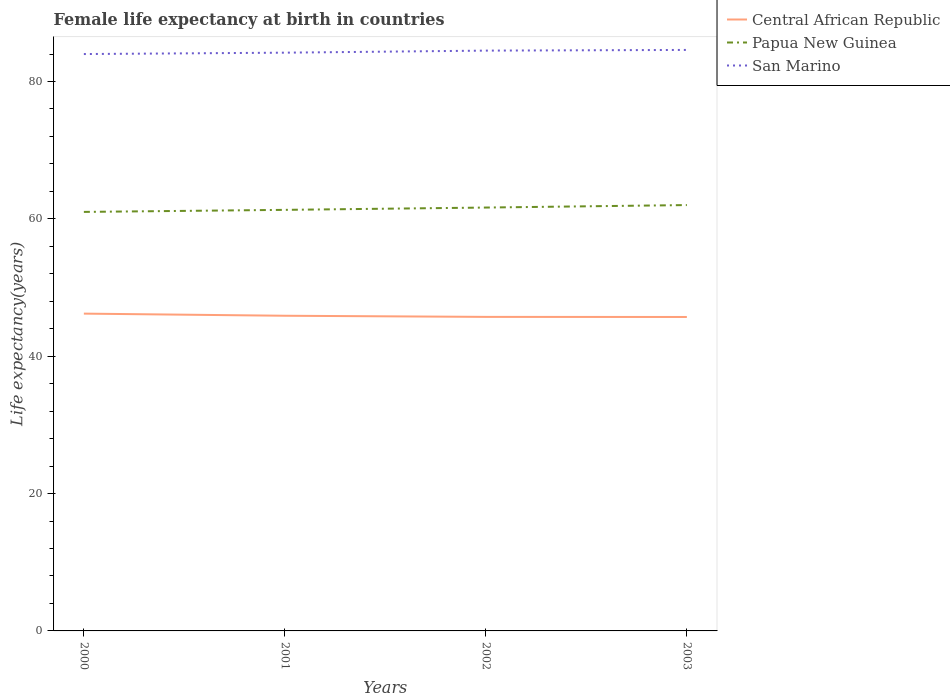How many different coloured lines are there?
Offer a very short reply. 3. In which year was the female life expectancy at birth in Central African Republic maximum?
Offer a very short reply. 2003. What is the total female life expectancy at birth in San Marino in the graph?
Your answer should be very brief. -0.1. What is the difference between the highest and the second highest female life expectancy at birth in Papua New Guinea?
Provide a short and direct response. 1. What is the difference between the highest and the lowest female life expectancy at birth in Papua New Guinea?
Your answer should be compact. 2. Is the female life expectancy at birth in Central African Republic strictly greater than the female life expectancy at birth in San Marino over the years?
Keep it short and to the point. Yes. What is the difference between two consecutive major ticks on the Y-axis?
Offer a terse response. 20. Are the values on the major ticks of Y-axis written in scientific E-notation?
Your answer should be compact. No. Where does the legend appear in the graph?
Provide a short and direct response. Top right. How many legend labels are there?
Ensure brevity in your answer.  3. How are the legend labels stacked?
Your response must be concise. Vertical. What is the title of the graph?
Ensure brevity in your answer.  Female life expectancy at birth in countries. What is the label or title of the X-axis?
Your answer should be compact. Years. What is the label or title of the Y-axis?
Offer a very short reply. Life expectancy(years). What is the Life expectancy(years) in Central African Republic in 2000?
Keep it short and to the point. 46.2. What is the Life expectancy(years) of Papua New Guinea in 2000?
Offer a terse response. 61.01. What is the Life expectancy(years) of San Marino in 2000?
Provide a short and direct response. 84. What is the Life expectancy(years) of Central African Republic in 2001?
Your response must be concise. 45.89. What is the Life expectancy(years) in Papua New Guinea in 2001?
Keep it short and to the point. 61.31. What is the Life expectancy(years) of San Marino in 2001?
Ensure brevity in your answer.  84.2. What is the Life expectancy(years) of Central African Republic in 2002?
Give a very brief answer. 45.73. What is the Life expectancy(years) of Papua New Guinea in 2002?
Offer a terse response. 61.65. What is the Life expectancy(years) of San Marino in 2002?
Give a very brief answer. 84.5. What is the Life expectancy(years) of Central African Republic in 2003?
Provide a short and direct response. 45.71. What is the Life expectancy(years) of Papua New Guinea in 2003?
Provide a succinct answer. 62.01. What is the Life expectancy(years) in San Marino in 2003?
Give a very brief answer. 84.6. Across all years, what is the maximum Life expectancy(years) in Central African Republic?
Offer a very short reply. 46.2. Across all years, what is the maximum Life expectancy(years) in Papua New Guinea?
Provide a succinct answer. 62.01. Across all years, what is the maximum Life expectancy(years) of San Marino?
Make the answer very short. 84.6. Across all years, what is the minimum Life expectancy(years) of Central African Republic?
Ensure brevity in your answer.  45.71. Across all years, what is the minimum Life expectancy(years) of Papua New Guinea?
Keep it short and to the point. 61.01. Across all years, what is the minimum Life expectancy(years) of San Marino?
Your answer should be compact. 84. What is the total Life expectancy(years) of Central African Republic in the graph?
Provide a short and direct response. 183.53. What is the total Life expectancy(years) in Papua New Guinea in the graph?
Provide a short and direct response. 245.98. What is the total Life expectancy(years) of San Marino in the graph?
Make the answer very short. 337.3. What is the difference between the Life expectancy(years) of Central African Republic in 2000 and that in 2001?
Offer a very short reply. 0.31. What is the difference between the Life expectancy(years) of Papua New Guinea in 2000 and that in 2001?
Your response must be concise. -0.3. What is the difference between the Life expectancy(years) of Central African Republic in 2000 and that in 2002?
Ensure brevity in your answer.  0.47. What is the difference between the Life expectancy(years) of Papua New Guinea in 2000 and that in 2002?
Keep it short and to the point. -0.64. What is the difference between the Life expectancy(years) of Central African Republic in 2000 and that in 2003?
Provide a succinct answer. 0.49. What is the difference between the Life expectancy(years) in Papua New Guinea in 2000 and that in 2003?
Give a very brief answer. -1. What is the difference between the Life expectancy(years) in San Marino in 2000 and that in 2003?
Your response must be concise. -0.6. What is the difference between the Life expectancy(years) of Central African Republic in 2001 and that in 2002?
Provide a succinct answer. 0.17. What is the difference between the Life expectancy(years) of Papua New Guinea in 2001 and that in 2002?
Provide a succinct answer. -0.34. What is the difference between the Life expectancy(years) of San Marino in 2001 and that in 2002?
Make the answer very short. -0.3. What is the difference between the Life expectancy(years) of Central African Republic in 2001 and that in 2003?
Give a very brief answer. 0.18. What is the difference between the Life expectancy(years) in Papua New Guinea in 2001 and that in 2003?
Your response must be concise. -0.7. What is the difference between the Life expectancy(years) in San Marino in 2001 and that in 2003?
Offer a terse response. -0.4. What is the difference between the Life expectancy(years) in Central African Republic in 2002 and that in 2003?
Your response must be concise. 0.01. What is the difference between the Life expectancy(years) of Papua New Guinea in 2002 and that in 2003?
Give a very brief answer. -0.36. What is the difference between the Life expectancy(years) in San Marino in 2002 and that in 2003?
Your answer should be very brief. -0.1. What is the difference between the Life expectancy(years) in Central African Republic in 2000 and the Life expectancy(years) in Papua New Guinea in 2001?
Provide a short and direct response. -15.11. What is the difference between the Life expectancy(years) of Central African Republic in 2000 and the Life expectancy(years) of San Marino in 2001?
Ensure brevity in your answer.  -38. What is the difference between the Life expectancy(years) of Papua New Guinea in 2000 and the Life expectancy(years) of San Marino in 2001?
Your response must be concise. -23.19. What is the difference between the Life expectancy(years) of Central African Republic in 2000 and the Life expectancy(years) of Papua New Guinea in 2002?
Offer a very short reply. -15.45. What is the difference between the Life expectancy(years) in Central African Republic in 2000 and the Life expectancy(years) in San Marino in 2002?
Your answer should be compact. -38.3. What is the difference between the Life expectancy(years) in Papua New Guinea in 2000 and the Life expectancy(years) in San Marino in 2002?
Offer a very short reply. -23.49. What is the difference between the Life expectancy(years) in Central African Republic in 2000 and the Life expectancy(years) in Papua New Guinea in 2003?
Offer a very short reply. -15.81. What is the difference between the Life expectancy(years) in Central African Republic in 2000 and the Life expectancy(years) in San Marino in 2003?
Your answer should be very brief. -38.4. What is the difference between the Life expectancy(years) in Papua New Guinea in 2000 and the Life expectancy(years) in San Marino in 2003?
Your response must be concise. -23.59. What is the difference between the Life expectancy(years) in Central African Republic in 2001 and the Life expectancy(years) in Papua New Guinea in 2002?
Your answer should be compact. -15.76. What is the difference between the Life expectancy(years) of Central African Republic in 2001 and the Life expectancy(years) of San Marino in 2002?
Your answer should be very brief. -38.61. What is the difference between the Life expectancy(years) in Papua New Guinea in 2001 and the Life expectancy(years) in San Marino in 2002?
Your answer should be compact. -23.19. What is the difference between the Life expectancy(years) in Central African Republic in 2001 and the Life expectancy(years) in Papua New Guinea in 2003?
Your answer should be very brief. -16.12. What is the difference between the Life expectancy(years) of Central African Republic in 2001 and the Life expectancy(years) of San Marino in 2003?
Your answer should be compact. -38.71. What is the difference between the Life expectancy(years) in Papua New Guinea in 2001 and the Life expectancy(years) in San Marino in 2003?
Your answer should be very brief. -23.29. What is the difference between the Life expectancy(years) of Central African Republic in 2002 and the Life expectancy(years) of Papua New Guinea in 2003?
Ensure brevity in your answer.  -16.28. What is the difference between the Life expectancy(years) of Central African Republic in 2002 and the Life expectancy(years) of San Marino in 2003?
Your response must be concise. -38.87. What is the difference between the Life expectancy(years) in Papua New Guinea in 2002 and the Life expectancy(years) in San Marino in 2003?
Your answer should be very brief. -22.95. What is the average Life expectancy(years) of Central African Republic per year?
Offer a very short reply. 45.88. What is the average Life expectancy(years) in Papua New Guinea per year?
Provide a succinct answer. 61.5. What is the average Life expectancy(years) in San Marino per year?
Your response must be concise. 84.33. In the year 2000, what is the difference between the Life expectancy(years) of Central African Republic and Life expectancy(years) of Papua New Guinea?
Your answer should be compact. -14.81. In the year 2000, what is the difference between the Life expectancy(years) of Central African Republic and Life expectancy(years) of San Marino?
Make the answer very short. -37.8. In the year 2000, what is the difference between the Life expectancy(years) in Papua New Guinea and Life expectancy(years) in San Marino?
Your response must be concise. -22.99. In the year 2001, what is the difference between the Life expectancy(years) of Central African Republic and Life expectancy(years) of Papua New Guinea?
Provide a succinct answer. -15.42. In the year 2001, what is the difference between the Life expectancy(years) in Central African Republic and Life expectancy(years) in San Marino?
Give a very brief answer. -38.31. In the year 2001, what is the difference between the Life expectancy(years) in Papua New Guinea and Life expectancy(years) in San Marino?
Your answer should be very brief. -22.89. In the year 2002, what is the difference between the Life expectancy(years) of Central African Republic and Life expectancy(years) of Papua New Guinea?
Keep it short and to the point. -15.92. In the year 2002, what is the difference between the Life expectancy(years) of Central African Republic and Life expectancy(years) of San Marino?
Your answer should be very brief. -38.77. In the year 2002, what is the difference between the Life expectancy(years) in Papua New Guinea and Life expectancy(years) in San Marino?
Offer a very short reply. -22.85. In the year 2003, what is the difference between the Life expectancy(years) in Central African Republic and Life expectancy(years) in Papua New Guinea?
Ensure brevity in your answer.  -16.3. In the year 2003, what is the difference between the Life expectancy(years) of Central African Republic and Life expectancy(years) of San Marino?
Ensure brevity in your answer.  -38.89. In the year 2003, what is the difference between the Life expectancy(years) in Papua New Guinea and Life expectancy(years) in San Marino?
Your response must be concise. -22.59. What is the ratio of the Life expectancy(years) of Central African Republic in 2000 to that in 2001?
Ensure brevity in your answer.  1.01. What is the ratio of the Life expectancy(years) of San Marino in 2000 to that in 2001?
Provide a short and direct response. 1. What is the ratio of the Life expectancy(years) of Central African Republic in 2000 to that in 2002?
Your answer should be compact. 1.01. What is the ratio of the Life expectancy(years) of Central African Republic in 2000 to that in 2003?
Your answer should be compact. 1.01. What is the ratio of the Life expectancy(years) of Papua New Guinea in 2000 to that in 2003?
Give a very brief answer. 0.98. What is the ratio of the Life expectancy(years) in San Marino in 2000 to that in 2003?
Keep it short and to the point. 0.99. What is the ratio of the Life expectancy(years) of Papua New Guinea in 2001 to that in 2003?
Provide a succinct answer. 0.99. What is the ratio of the Life expectancy(years) in San Marino in 2001 to that in 2003?
Provide a short and direct response. 1. What is the ratio of the Life expectancy(years) of San Marino in 2002 to that in 2003?
Your answer should be compact. 1. What is the difference between the highest and the second highest Life expectancy(years) of Central African Republic?
Offer a terse response. 0.31. What is the difference between the highest and the second highest Life expectancy(years) in Papua New Guinea?
Your answer should be compact. 0.36. What is the difference between the highest and the lowest Life expectancy(years) in Central African Republic?
Your response must be concise. 0.49. 